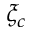Convert formula to latex. <formula><loc_0><loc_0><loc_500><loc_500>\xi _ { c }</formula> 